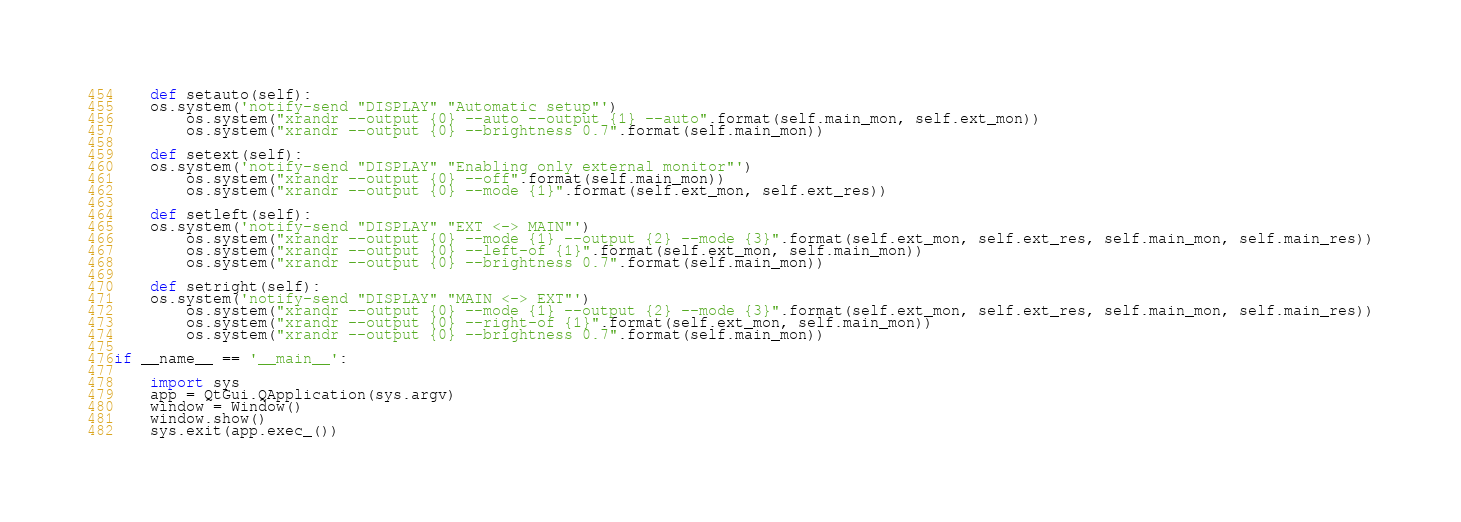Convert code to text. <code><loc_0><loc_0><loc_500><loc_500><_Python_>
    def setauto(self):
	os.system('notify-send "DISPLAY" "Automatic setup"')
        os.system("xrandr --output {0} --auto --output {1} --auto".format(self.main_mon, self.ext_mon))
        os.system("xrandr --output {0} --brightness 0.7".format(self.main_mon))

    def setext(self):
	os.system('notify-send "DISPLAY" "Enabling only external monitor"')
        os.system("xrandr --output {0} --off".format(self.main_mon))
        os.system("xrandr --output {0} --mode {1}".format(self.ext_mon, self.ext_res))
	
    def setleft(self):
	os.system('notify-send "DISPLAY" "EXT <-> MAIN"')
        os.system("xrandr --output {0} --mode {1} --output {2} --mode {3}".format(self.ext_mon, self.ext_res, self.main_mon, self.main_res))
        os.system("xrandr --output {0} --left-of {1}".format(self.ext_mon, self.main_mon))
        os.system("xrandr --output {0} --brightness 0.7".format(self.main_mon))
	
    def setright(self):
	os.system('notify-send "DISPLAY" "MAIN <-> EXT"')
        os.system("xrandr --output {0} --mode {1} --output {2} --mode {3}".format(self.ext_mon, self.ext_res, self.main_mon, self.main_res))
        os.system("xrandr --output {0} --right-of {1}".format(self.ext_mon, self.main_mon))
        os.system("xrandr --output {0} --brightness 0.7".format(self.main_mon))
	
if __name__ == '__main__':

    import sys
    app = QtGui.QApplication(sys.argv)
    window = Window()
    window.show()
    sys.exit(app.exec_())
</code> 